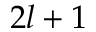<formula> <loc_0><loc_0><loc_500><loc_500>2 l + 1</formula> 